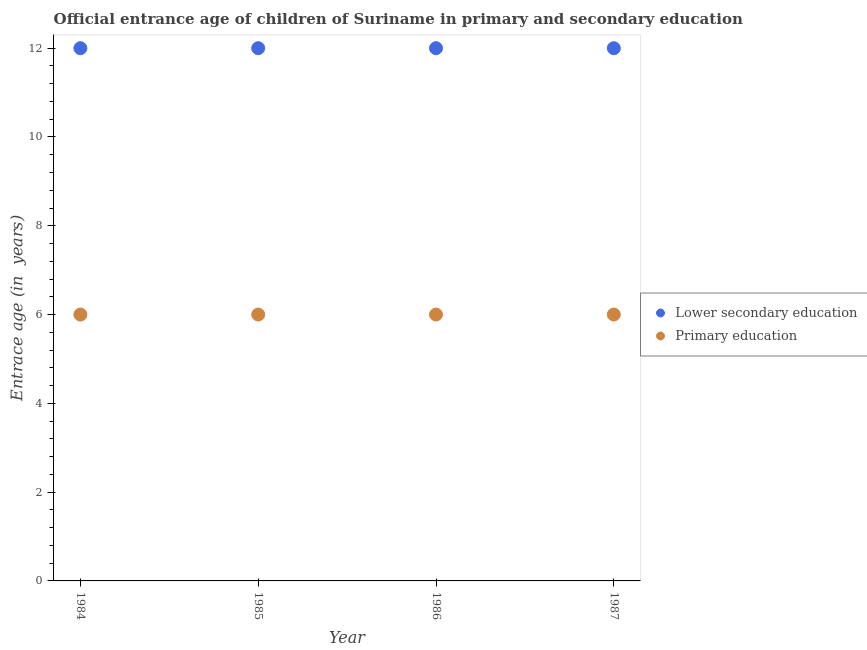How many different coloured dotlines are there?
Ensure brevity in your answer.  2. Is the number of dotlines equal to the number of legend labels?
Your answer should be compact. Yes. What is the entrance age of chiildren in primary education in 1985?
Make the answer very short. 6. Across all years, what is the minimum entrance age of children in lower secondary education?
Provide a succinct answer. 12. In which year was the entrance age of chiildren in primary education maximum?
Provide a short and direct response. 1984. What is the total entrance age of chiildren in primary education in the graph?
Keep it short and to the point. 24. What is the difference between the entrance age of children in lower secondary education in 1985 and that in 1986?
Keep it short and to the point. 0. What is the difference between the entrance age of chiildren in primary education in 1985 and the entrance age of children in lower secondary education in 1986?
Give a very brief answer. -6. In how many years, is the entrance age of children in lower secondary education greater than 6.8 years?
Ensure brevity in your answer.  4. What is the ratio of the entrance age of chiildren in primary education in 1984 to that in 1985?
Your answer should be very brief. 1. What is the difference between the highest and the lowest entrance age of chiildren in primary education?
Keep it short and to the point. 0. Is the sum of the entrance age of chiildren in primary education in 1984 and 1985 greater than the maximum entrance age of children in lower secondary education across all years?
Provide a succinct answer. No. Does the entrance age of chiildren in primary education monotonically increase over the years?
Ensure brevity in your answer.  No. Is the entrance age of children in lower secondary education strictly greater than the entrance age of chiildren in primary education over the years?
Offer a terse response. Yes. What is the difference between two consecutive major ticks on the Y-axis?
Your answer should be compact. 2. Are the values on the major ticks of Y-axis written in scientific E-notation?
Keep it short and to the point. No. How are the legend labels stacked?
Give a very brief answer. Vertical. What is the title of the graph?
Offer a terse response. Official entrance age of children of Suriname in primary and secondary education. What is the label or title of the Y-axis?
Provide a short and direct response. Entrace age (in  years). What is the Entrace age (in  years) of Lower secondary education in 1984?
Keep it short and to the point. 12. What is the Entrace age (in  years) in Lower secondary education in 1985?
Offer a terse response. 12. What is the Entrace age (in  years) in Primary education in 1985?
Give a very brief answer. 6. Across all years, what is the maximum Entrace age (in  years) in Primary education?
Keep it short and to the point. 6. Across all years, what is the minimum Entrace age (in  years) in Primary education?
Make the answer very short. 6. What is the difference between the Entrace age (in  years) of Primary education in 1984 and that in 1987?
Make the answer very short. 0. What is the difference between the Entrace age (in  years) of Primary education in 1985 and that in 1986?
Provide a short and direct response. 0. What is the difference between the Entrace age (in  years) in Lower secondary education in 1985 and that in 1987?
Your answer should be compact. 0. What is the difference between the Entrace age (in  years) of Primary education in 1985 and that in 1987?
Your response must be concise. 0. What is the difference between the Entrace age (in  years) of Primary education in 1986 and that in 1987?
Offer a very short reply. 0. What is the difference between the Entrace age (in  years) of Lower secondary education in 1984 and the Entrace age (in  years) of Primary education in 1985?
Give a very brief answer. 6. What is the difference between the Entrace age (in  years) of Lower secondary education in 1985 and the Entrace age (in  years) of Primary education in 1987?
Provide a succinct answer. 6. What is the average Entrace age (in  years) of Primary education per year?
Make the answer very short. 6. In the year 1984, what is the difference between the Entrace age (in  years) of Lower secondary education and Entrace age (in  years) of Primary education?
Your answer should be very brief. 6. In the year 1985, what is the difference between the Entrace age (in  years) of Lower secondary education and Entrace age (in  years) of Primary education?
Keep it short and to the point. 6. In the year 1986, what is the difference between the Entrace age (in  years) of Lower secondary education and Entrace age (in  years) of Primary education?
Offer a terse response. 6. What is the ratio of the Entrace age (in  years) in Lower secondary education in 1984 to that in 1985?
Your answer should be very brief. 1. What is the ratio of the Entrace age (in  years) of Primary education in 1984 to that in 1985?
Keep it short and to the point. 1. What is the ratio of the Entrace age (in  years) in Primary education in 1984 to that in 1986?
Keep it short and to the point. 1. What is the ratio of the Entrace age (in  years) of Primary education in 1985 to that in 1986?
Offer a very short reply. 1. What is the ratio of the Entrace age (in  years) in Primary education in 1985 to that in 1987?
Keep it short and to the point. 1. What is the ratio of the Entrace age (in  years) of Primary education in 1986 to that in 1987?
Your answer should be very brief. 1. What is the difference between the highest and the second highest Entrace age (in  years) of Primary education?
Ensure brevity in your answer.  0. What is the difference between the highest and the lowest Entrace age (in  years) in Lower secondary education?
Provide a short and direct response. 0. What is the difference between the highest and the lowest Entrace age (in  years) of Primary education?
Ensure brevity in your answer.  0. 